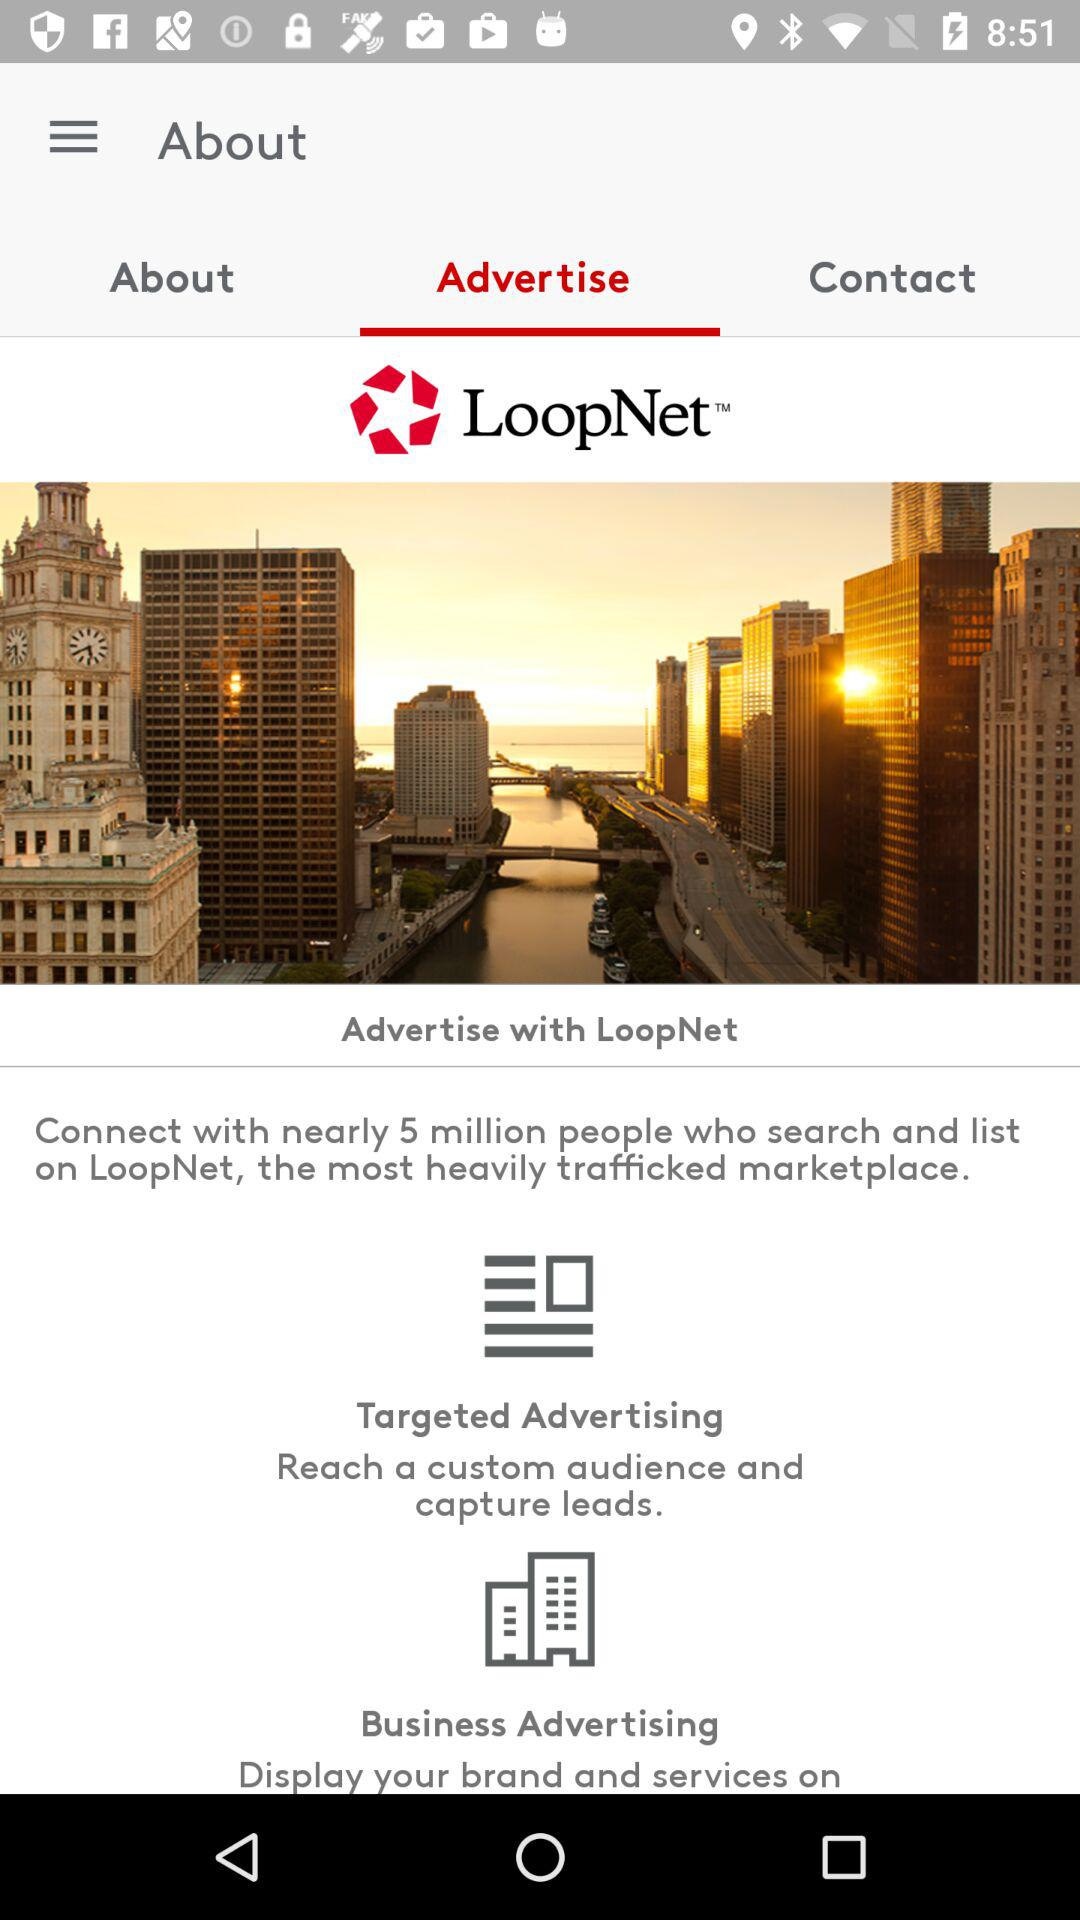Which tab is selected? The tab "Advertise" is selected. 